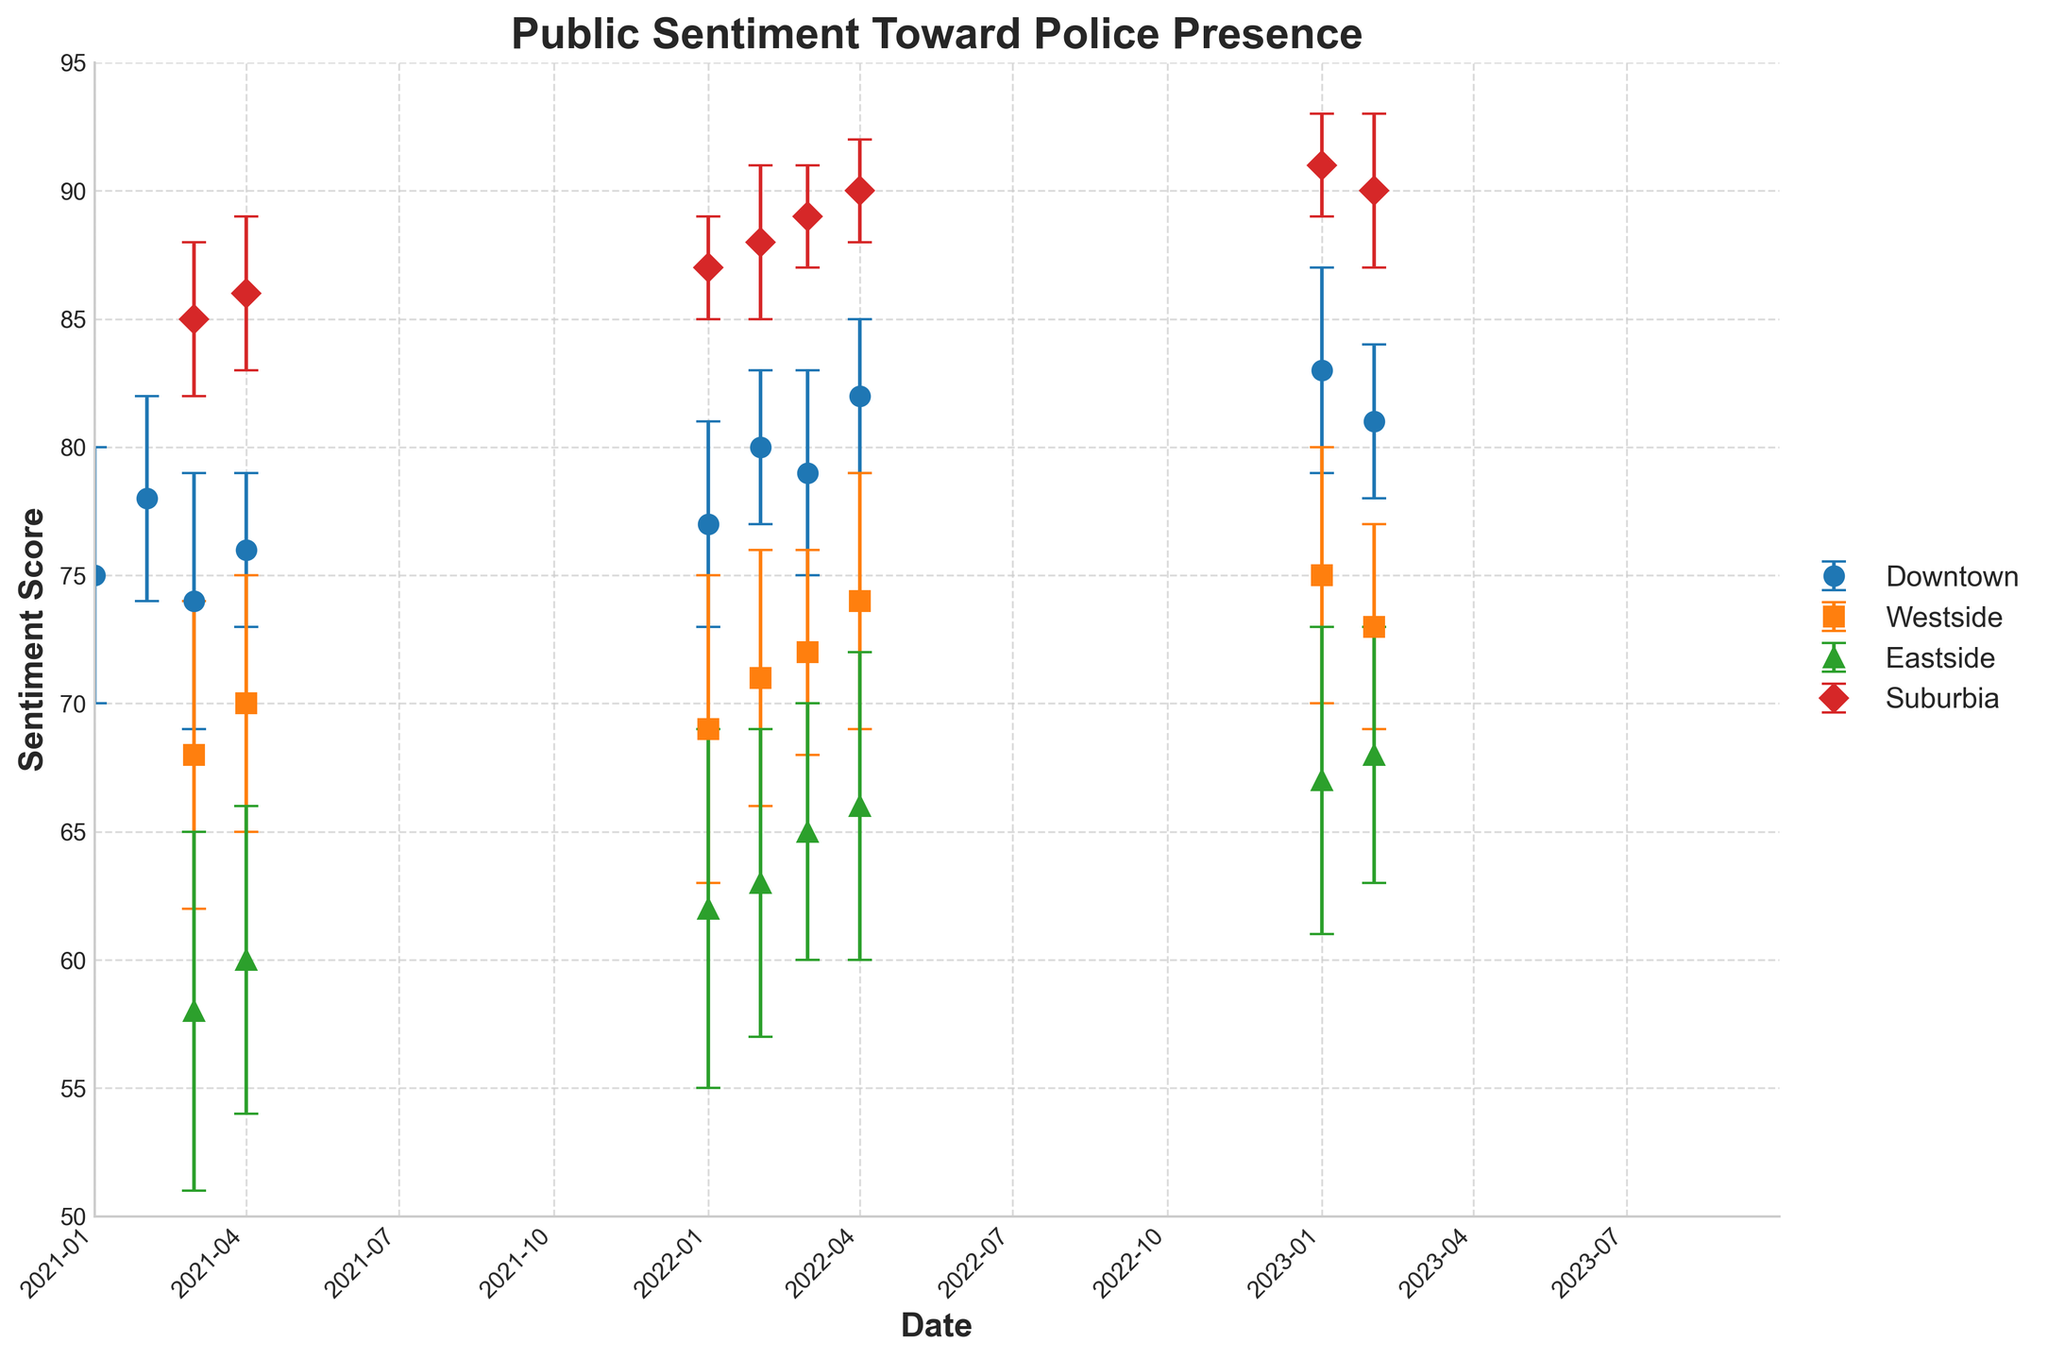What is the title of the figure? The title of the figure is the text at the top, which provides a summary of what the figure represents. In this case, it is clearly displayed.
Answer: Public Sentiment Toward Police Presence Which location has the highest average sentiment score throughout the observed period? To determine the highest average sentiment score, we need to compute the average sentiment score for all reported time points in each location and compare them.
Answer: Suburbia What is the sentiment score for Downtown for Q3 2022? Locate the data point for Downtown at Q3 2022 on the time series and read the sentiment score value.
Answer: 79 Compare the sentiment score range of Suburbia and Eastside in 2022. Which has a higher range? To compare the ranges, calculate the difference between the maximum and minimum sentiment scores in 2022 for both locations and compare these values.
Answer: Suburbia Which quarter and year did Downtown see the highest sentiment score? Identify the highest point on the Downtown line and note its corresponding quarter and year.
Answer: Q1 2023 Was the sentiment score in Eastside higher in Q4 2021 or Q1 2022? Check the sentiment scores for Eastside at Q4 2021 and Q1 2022 and compare them.
Answer: Q1 2022 How does the sentiment score trend in Westside from Q2 2022 to Q1 2023? Observe the trend of the Westside line from Q2 2022 to Q1 2023, noting whether it increases, decreases, or remains constant.
Answer: Increasing What is the average sentiment score for Downtown in 2022? Calculate the average sentiment score for Downtown by summing the scores for Q1 2022 to Q4 2022 and dividing by the number of quarters.
Answer: 79.5 Compare the error margins of Downtown and Eastside in Q2 2022. Which location has a larger error margin? Identify the error bars at Q2 2022 for both Downtown and Eastside and compare their lengths.
Answer: Eastside In which quarter and year does Suburbia show the lowest sentiment score? Locate the lowest point on the Suburbia line and note its corresponding quarter and year.
Answer: Q2 2023 